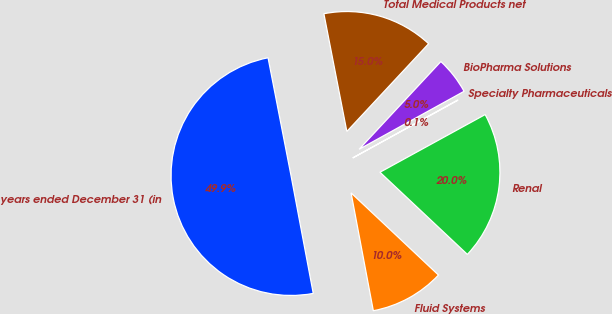Convert chart to OTSL. <chart><loc_0><loc_0><loc_500><loc_500><pie_chart><fcel>years ended December 31 (in<fcel>Fluid Systems<fcel>Renal<fcel>Specialty Pharmaceuticals<fcel>BioPharma Solutions<fcel>Total Medical Products net<nl><fcel>49.9%<fcel>10.02%<fcel>19.99%<fcel>0.05%<fcel>5.03%<fcel>15.0%<nl></chart> 